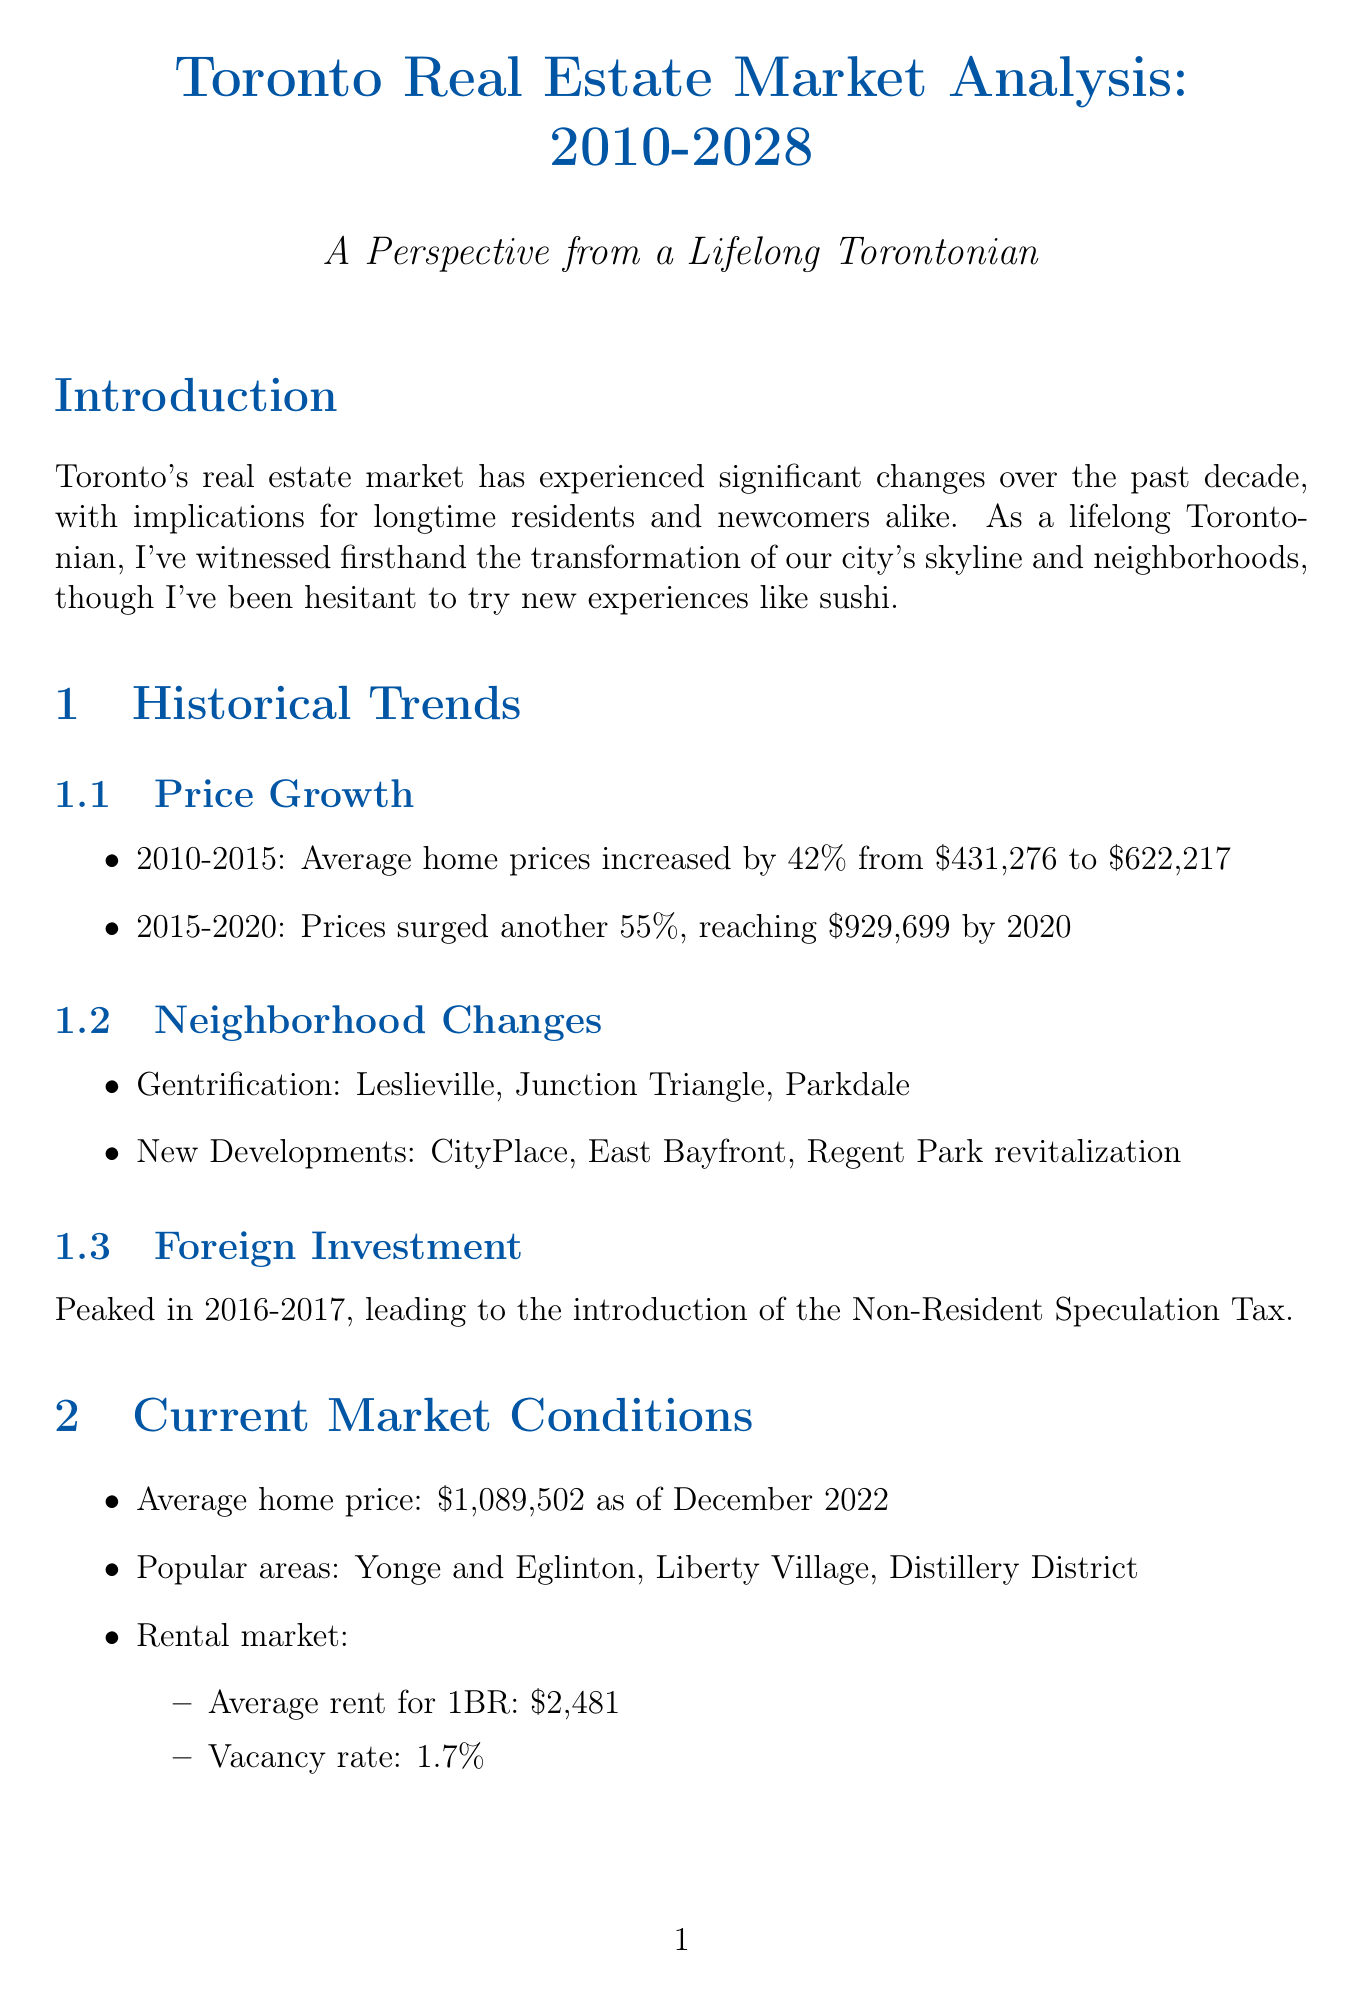What was the average home price in Toronto in December 2022? The document states the average home price as of December 2022 is $1,089,502.
Answer: $1,089,502 What percentage did home prices increase from 2010 to 2015? The document indicates that average home prices increased by 42% from 2010 to 2015.
Answer: 42% Which neighborhood is mentioned under gentrification? The document lists Leslieville as one of the neighborhoods affected by gentrification.
Answer: Leslieville What is the average rent for a 1-bedroom apartment? The document provides the average rent for a 1-bedroom apartment as $2,481.
Answer: $2,481 What are the projected emerging areas for Toronto from 2023 to 2028? The document states that the emerging areas include Downsview, Port Lands, and East Harbour.
Answer: Downsview, Port Lands, East Harbour How much is the average property tax bill expected to rise annually? The document mentions that the average property tax bill is expected to rise 5.5% annually.
Answer: 5.5% What long-term trend is predicted for home prices from 2026 to 2028? The document forecasts resumed strong growth in home prices during the period 2026 to 2028.
Answer: Resumed strong growth What major development is mentioned for the waterfront? The document refers to the Quayside development by Waterfront Toronto as a major infrastructure project.
Answer: Quayside development 